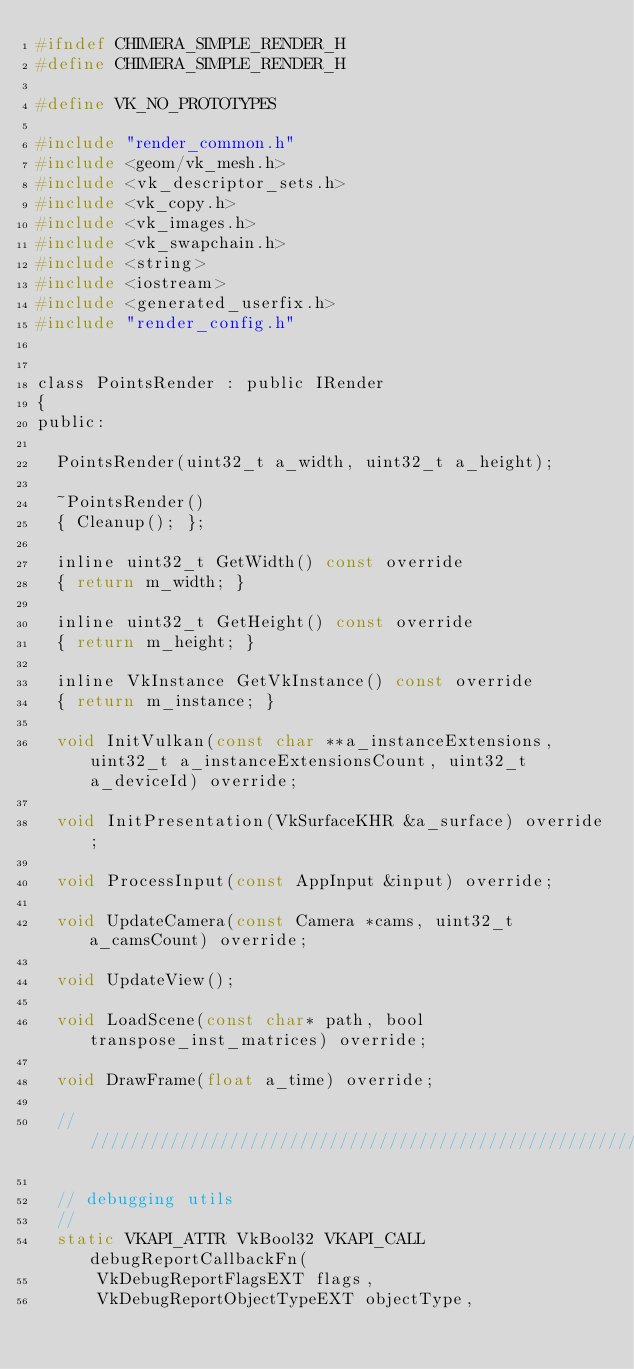<code> <loc_0><loc_0><loc_500><loc_500><_C_>#ifndef CHIMERA_SIMPLE_RENDER_H
#define CHIMERA_SIMPLE_RENDER_H

#define VK_NO_PROTOTYPES

#include "render_common.h"
#include <geom/vk_mesh.h>
#include <vk_descriptor_sets.h>
#include <vk_copy.h>
#include <vk_images.h>
#include <vk_swapchain.h>
#include <string>
#include <iostream>
#include <generated_userfix.h>
#include "render_config.h"


class PointsRender : public IRender
{
public:

  PointsRender(uint32_t a_width, uint32_t a_height);

  ~PointsRender()
  { Cleanup(); };

  inline uint32_t GetWidth() const override
  { return m_width; }

  inline uint32_t GetHeight() const override
  { return m_height; }

  inline VkInstance GetVkInstance() const override
  { return m_instance; }

  void InitVulkan(const char **a_instanceExtensions, uint32_t a_instanceExtensionsCount, uint32_t a_deviceId) override;

  void InitPresentation(VkSurfaceKHR &a_surface) override;

  void ProcessInput(const AppInput &input) override;

  void UpdateCamera(const Camera *cams, uint32_t a_camsCount) override;

  void UpdateView();

  void LoadScene(const char* path, bool transpose_inst_matrices) override;

  void DrawFrame(float a_time) override;

  //////////////////////////////////////////////////////////////////////////////////////////////////////////////////////////////////////////////

  // debugging utils
  //
  static VKAPI_ATTR VkBool32 VKAPI_CALL debugReportCallbackFn(
      VkDebugReportFlagsEXT flags,
      VkDebugReportObjectTypeEXT objectType,</code> 